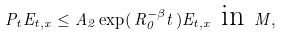Convert formula to latex. <formula><loc_0><loc_0><loc_500><loc_500>P _ { t } E _ { t , x } \leq A _ { 2 } \exp ( \, R _ { 0 } ^ { - \beta } t \, ) E _ { t , x } \text { in } M ,</formula> 